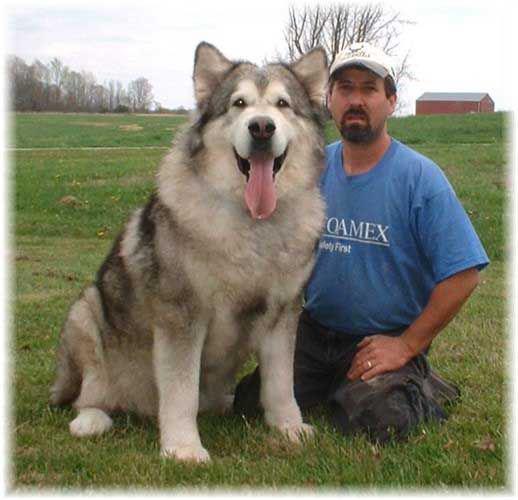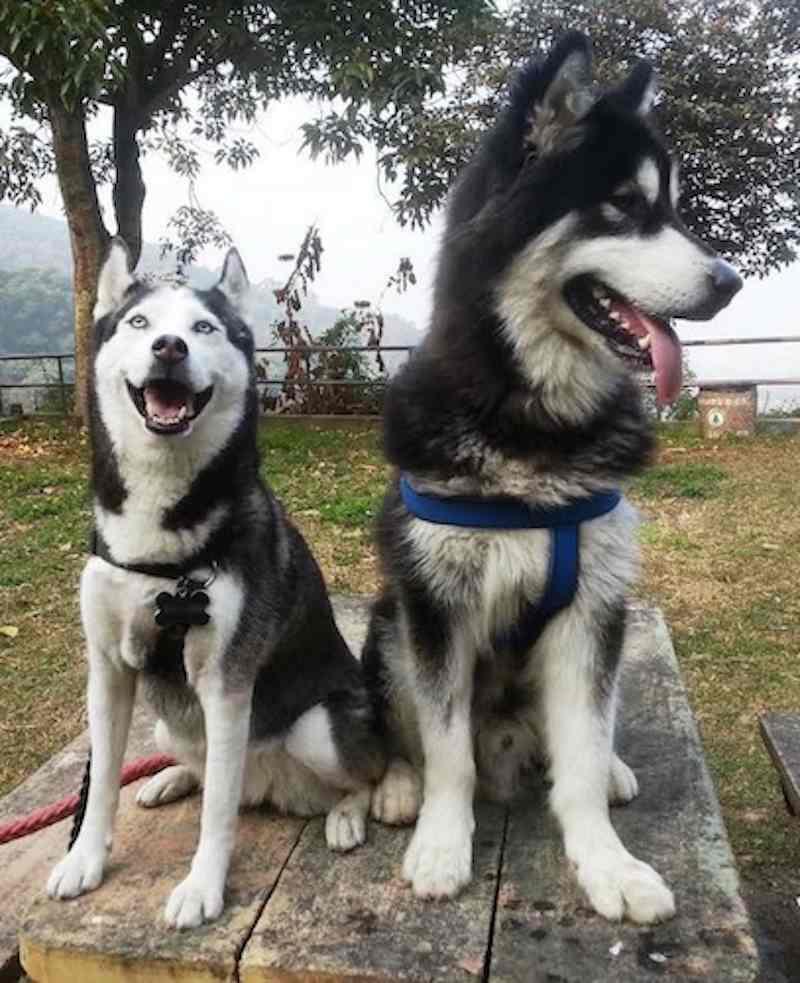The first image is the image on the left, the second image is the image on the right. Evaluate the accuracy of this statement regarding the images: "There is a person in a green top standing near the dog.". Is it true? Answer yes or no. No. The first image is the image on the left, the second image is the image on the right. Examine the images to the left and right. Is the description "The right image contains at least two dogs." accurate? Answer yes or no. Yes. 